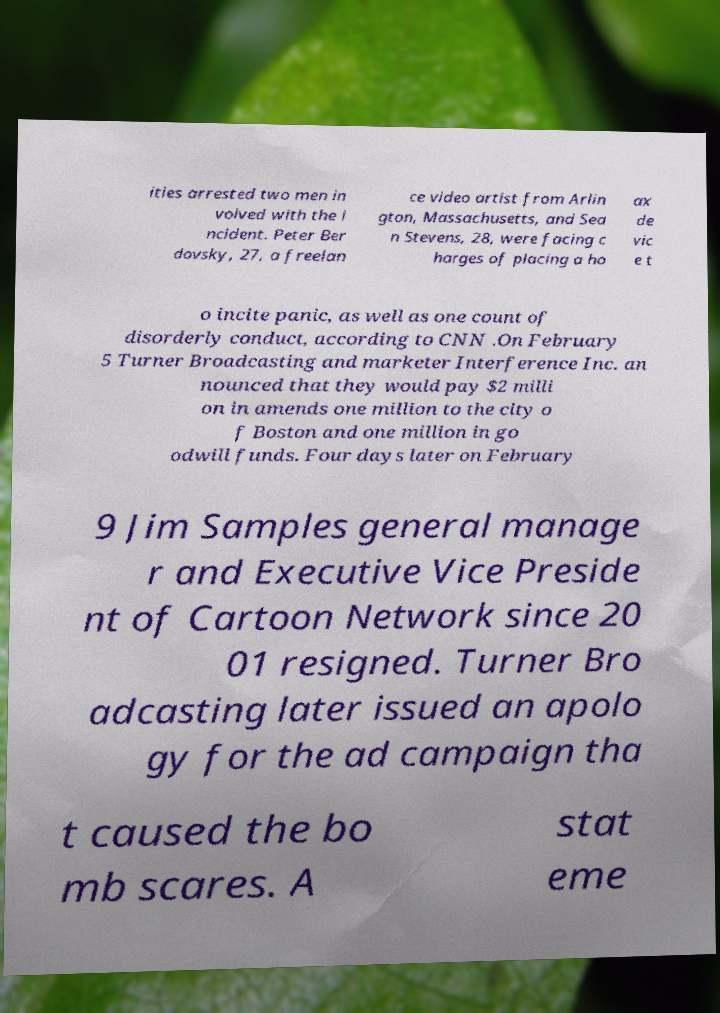Can you read and provide the text displayed in the image?This photo seems to have some interesting text. Can you extract and type it out for me? ities arrested two men in volved with the i ncident. Peter Ber dovsky, 27, a freelan ce video artist from Arlin gton, Massachusetts, and Sea n Stevens, 28, were facing c harges of placing a ho ax de vic e t o incite panic, as well as one count of disorderly conduct, according to CNN .On February 5 Turner Broadcasting and marketer Interference Inc. an nounced that they would pay $2 milli on in amends one million to the city o f Boston and one million in go odwill funds. Four days later on February 9 Jim Samples general manage r and Executive Vice Preside nt of Cartoon Network since 20 01 resigned. Turner Bro adcasting later issued an apolo gy for the ad campaign tha t caused the bo mb scares. A stat eme 